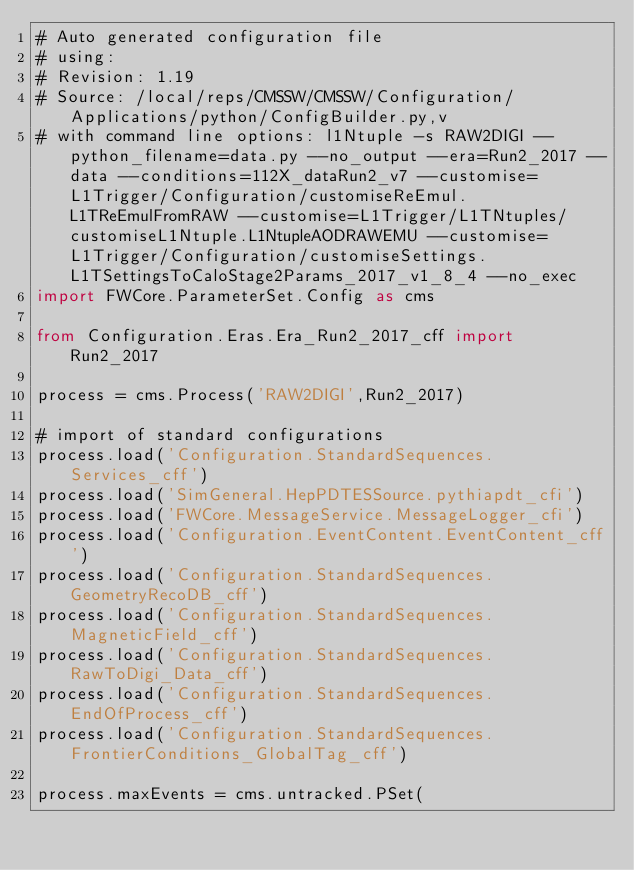Convert code to text. <code><loc_0><loc_0><loc_500><loc_500><_Python_># Auto generated configuration file
# using:
# Revision: 1.19
# Source: /local/reps/CMSSW/CMSSW/Configuration/Applications/python/ConfigBuilder.py,v
# with command line options: l1Ntuple -s RAW2DIGI --python_filename=data.py --no_output --era=Run2_2017 --data --conditions=112X_dataRun2_v7 --customise=L1Trigger/Configuration/customiseReEmul.L1TReEmulFromRAW --customise=L1Trigger/L1TNtuples/customiseL1Ntuple.L1NtupleAODRAWEMU --customise=L1Trigger/Configuration/customiseSettings.L1TSettingsToCaloStage2Params_2017_v1_8_4 --no_exec
import FWCore.ParameterSet.Config as cms

from Configuration.Eras.Era_Run2_2017_cff import Run2_2017

process = cms.Process('RAW2DIGI',Run2_2017)

# import of standard configurations
process.load('Configuration.StandardSequences.Services_cff')
process.load('SimGeneral.HepPDTESSource.pythiapdt_cfi')
process.load('FWCore.MessageService.MessageLogger_cfi')
process.load('Configuration.EventContent.EventContent_cff')
process.load('Configuration.StandardSequences.GeometryRecoDB_cff')
process.load('Configuration.StandardSequences.MagneticField_cff')
process.load('Configuration.StandardSequences.RawToDigi_Data_cff')
process.load('Configuration.StandardSequences.EndOfProcess_cff')
process.load('Configuration.StandardSequences.FrontierConditions_GlobalTag_cff')

process.maxEvents = cms.untracked.PSet(</code> 